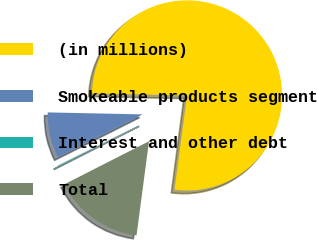<chart> <loc_0><loc_0><loc_500><loc_500><pie_chart><fcel>(in millions)<fcel>Smokeable products segment<fcel>Interest and other debt<fcel>Total<nl><fcel>76.76%<fcel>7.75%<fcel>0.08%<fcel>15.41%<nl></chart> 